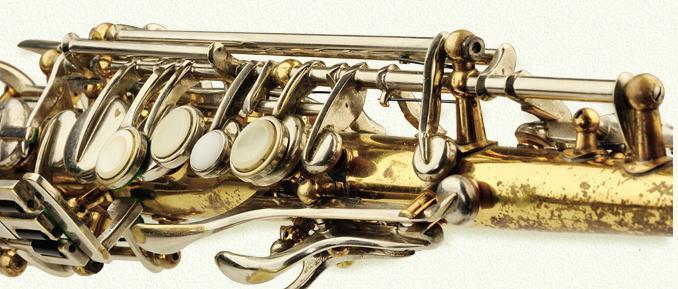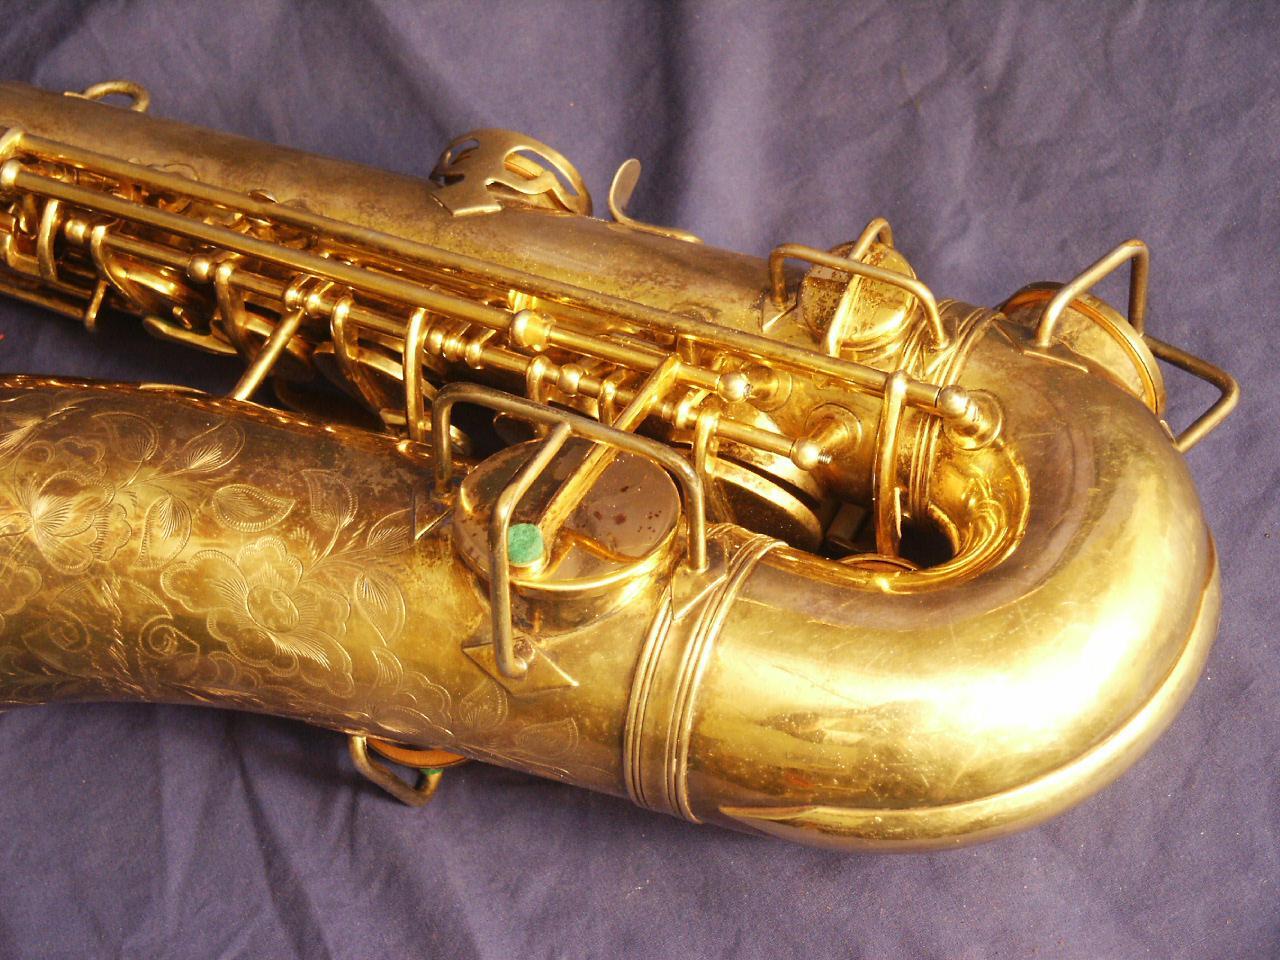The first image is the image on the left, the second image is the image on the right. Given the left and right images, does the statement "A section of a brass-colored instrument containing button and lever shapes is displayed on a white background." hold true? Answer yes or no. Yes. 